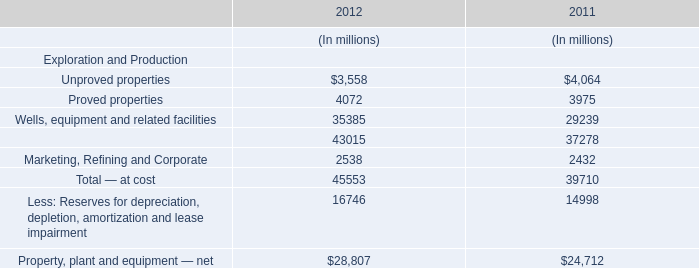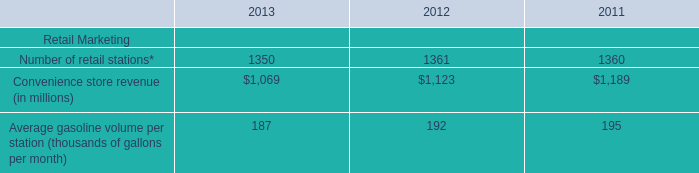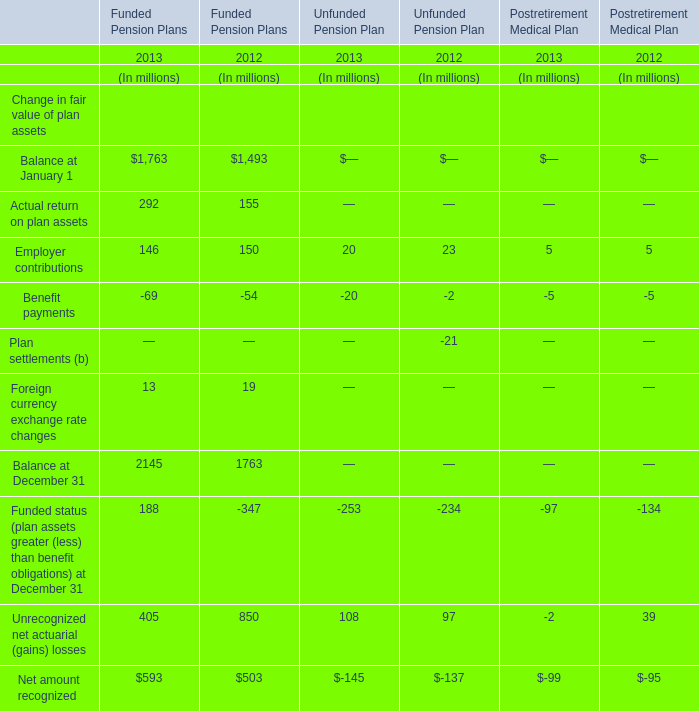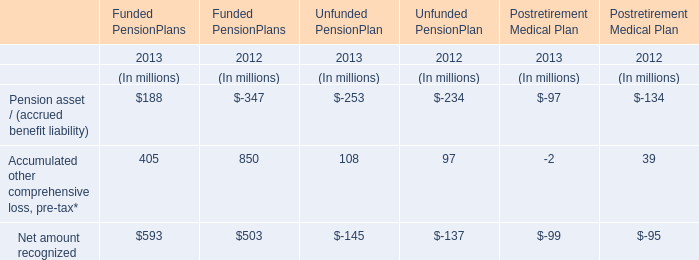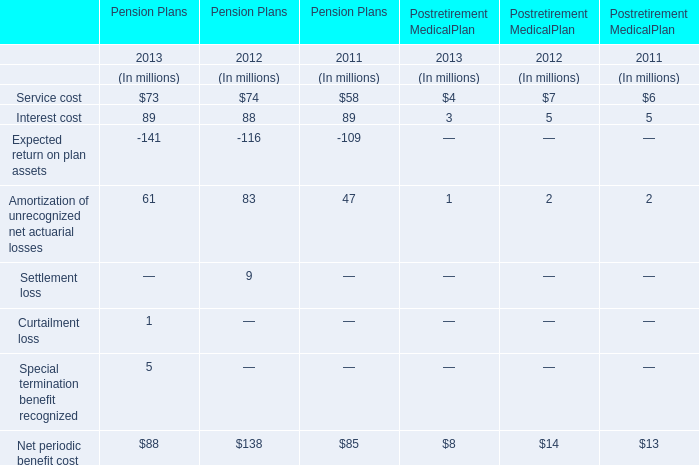What's the average of Balance at January 1 for Funded Pension Plans (in million) 
Computations: ((1763 + 1493) / 2)
Answer: 1628.0. 